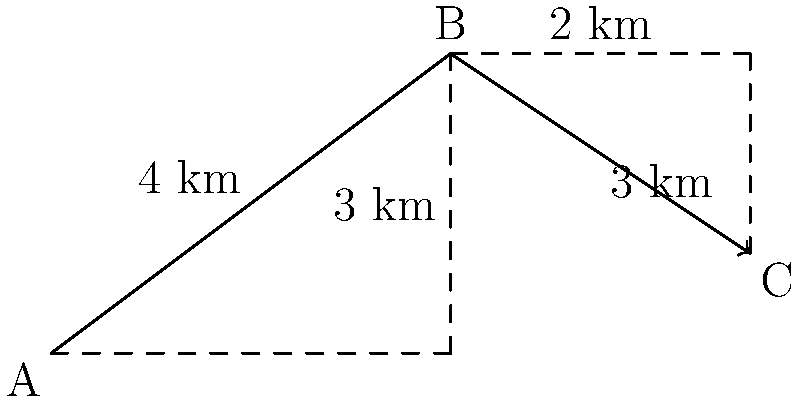In a fortified complex, supplies need to be moved from point A to point C via point B. The path from A to B is 4 km long with a vertical rise of 3 km, while the path from B to C is 3 km long with a vertical drop of 2 km. If a constant force of 500 N is required to move the supplies, calculate the total work done in moving the supplies from A to C. To solve this problem, we need to follow these steps:

1. Calculate the displacement vectors:
   Vector AB: $\vec{AB} = (4\hat{i} + 3\hat{j})$ km
   Vector BC: $\vec{BC} = (3\hat{i} - 2\hat{j})$ km

2. Calculate the magnitudes of these vectors:
   $|\vec{AB}| = \sqrt{4^2 + 3^2} = 5$ km
   $|\vec{BC}| = \sqrt{3^2 + (-2)^2} = \sqrt{13}$ km

3. Calculate the total distance:
   Total distance = $|\vec{AB}| + |\vec{BC}| = 5 + \sqrt{13}$ km

4. Use the work formula: $W = F \cdot d$
   Where $W$ is work, $F$ is force, and $d$ is distance

5. Substitute the values:
   $W = 500 \text{ N} \cdot (5 + \sqrt{13}) \text{ km}$

6. Convert km to m:
   $W = 500 \text{ N} \cdot (5000 + 1000\sqrt{13}) \text{ m}$

7. Calculate the final result:
   $W = 2,500,000 + 500,000\sqrt{13} \text{ J}$
Answer: $2,500,000 + 500,000\sqrt{13}$ J 